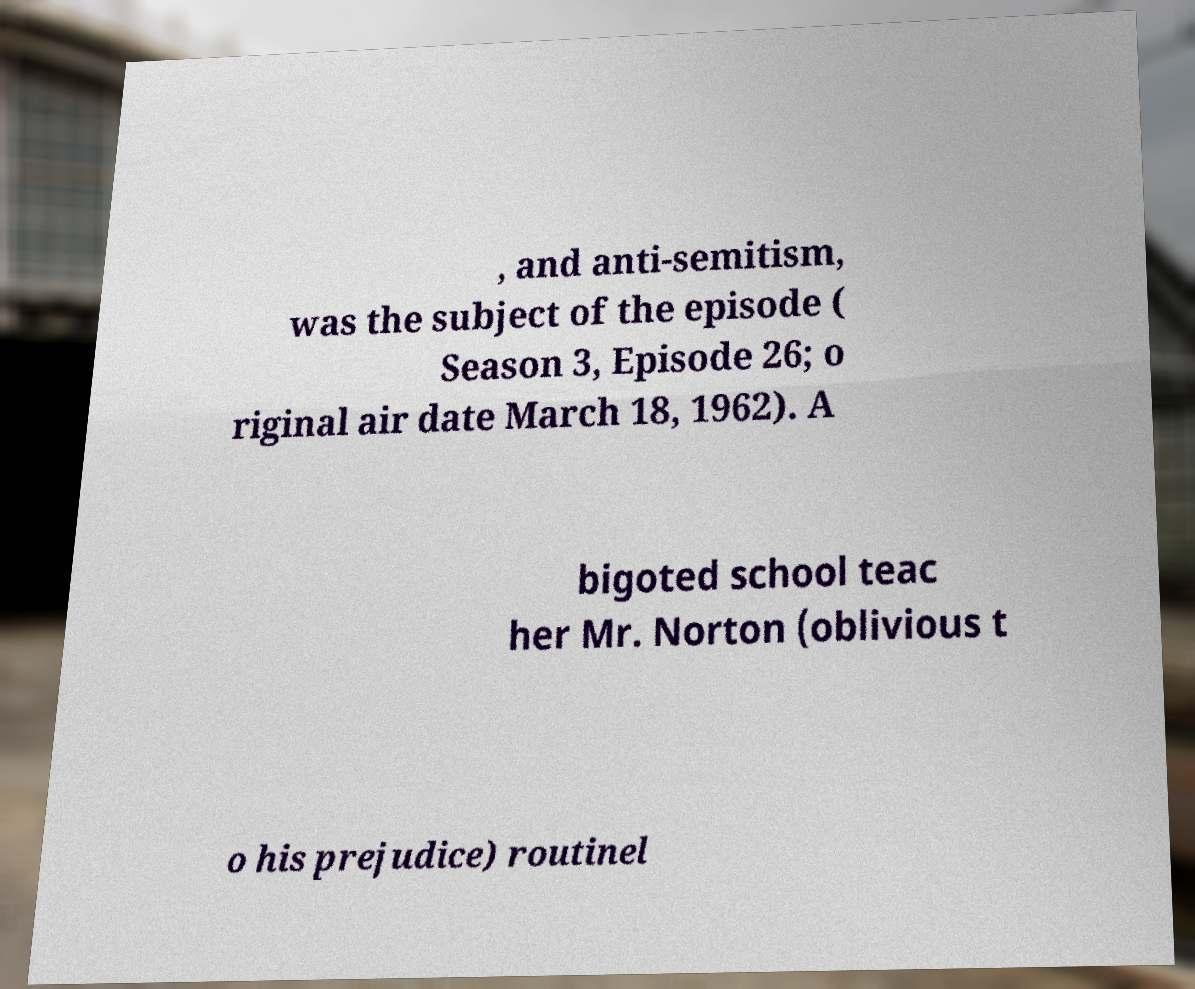Can you read and provide the text displayed in the image?This photo seems to have some interesting text. Can you extract and type it out for me? , and anti-semitism, was the subject of the episode ( Season 3, Episode 26; o riginal air date March 18, 1962). A bigoted school teac her Mr. Norton (oblivious t o his prejudice) routinel 